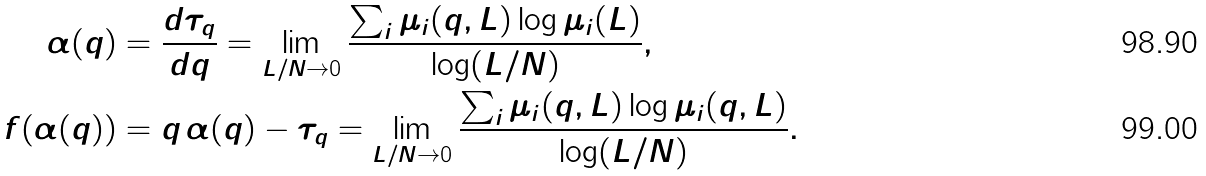Convert formula to latex. <formula><loc_0><loc_0><loc_500><loc_500>\alpha ( q ) & = \frac { d \tau _ { q } } { d q } = \lim _ { L / N \to 0 } \frac { \sum _ { i } \mu _ { i } ( q , L ) \log \mu _ { i } ( L ) } { \log ( L / N ) } , \\ f ( \alpha ( q ) ) & = q \, \alpha ( q ) - \tau _ { q } = \lim _ { L / N \to 0 } \frac { \sum _ { i } \mu _ { i } ( q , L ) \log \mu _ { i } ( q , L ) } { \log ( L / N ) } .</formula> 